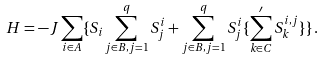Convert formula to latex. <formula><loc_0><loc_0><loc_500><loc_500>H = - J \sum _ { i \in A } \{ S _ { i } \sum _ { j \in B , j = 1 } ^ { q } S _ { j } ^ { i } + \sum _ { j \in B , j = 1 } ^ { q } S _ { j } ^ { i } \{ \sum _ { k \in C } ^ { \prime } S _ { k } ^ { i , j } \} \} \, .</formula> 